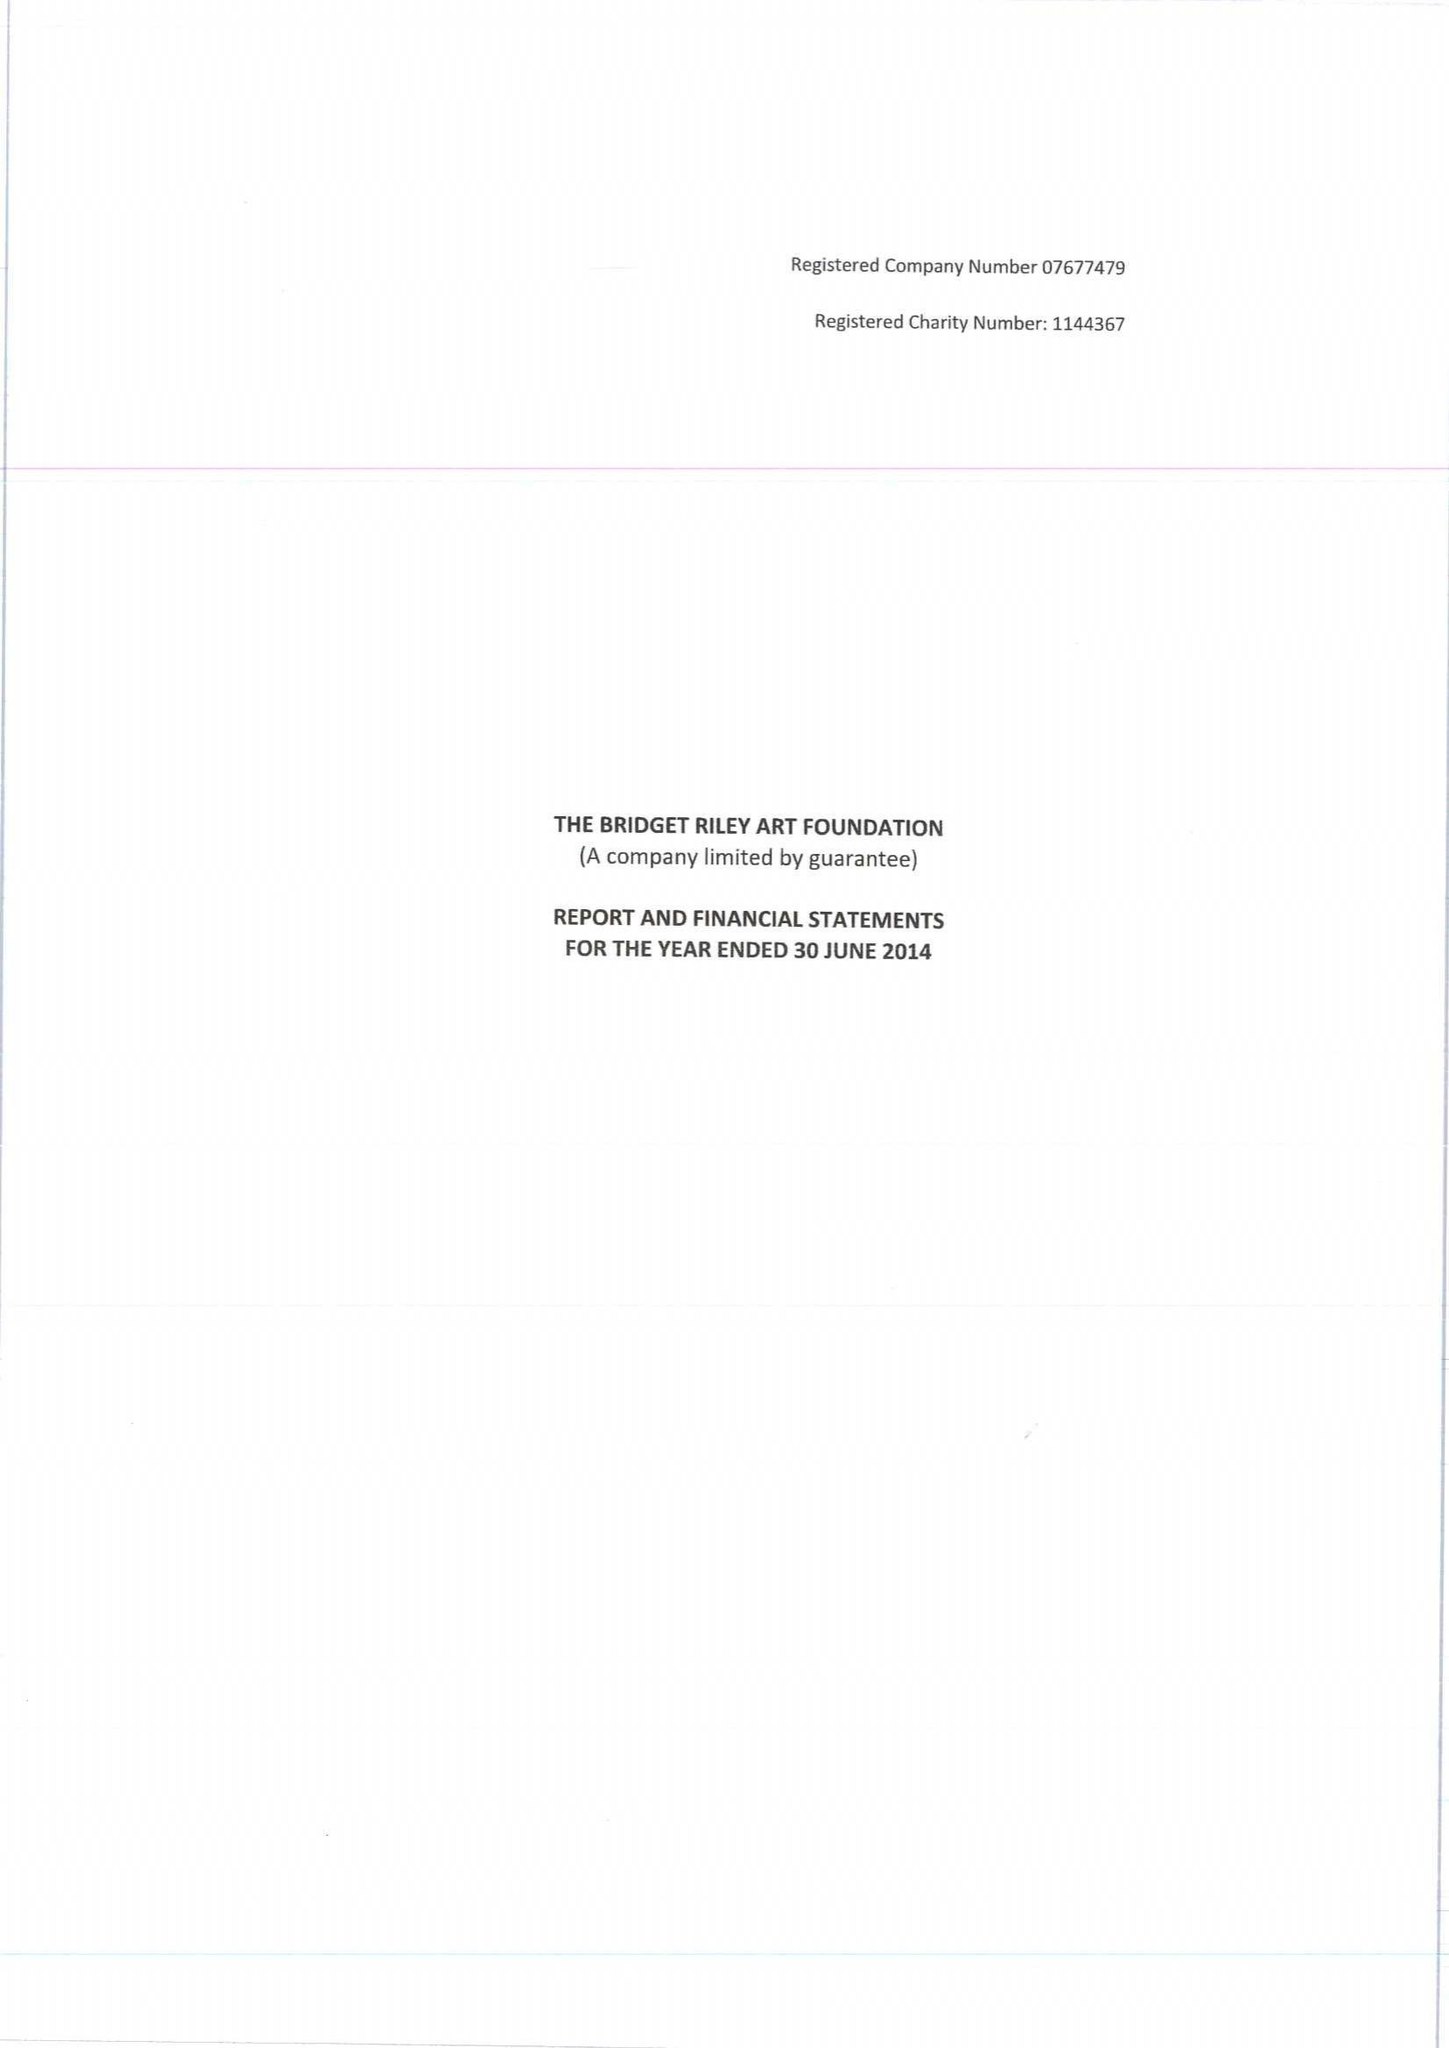What is the value for the address__postcode?
Answer the question using a single word or phrase. W11 4SL 